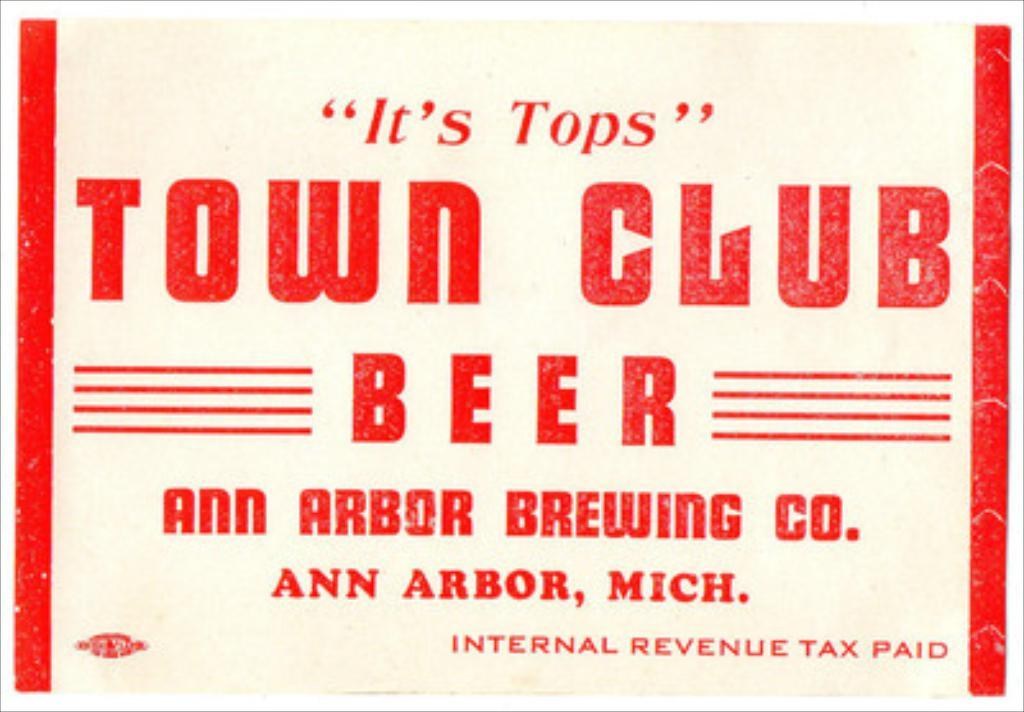<image>
Relay a brief, clear account of the picture shown. some red text that says town club on it 